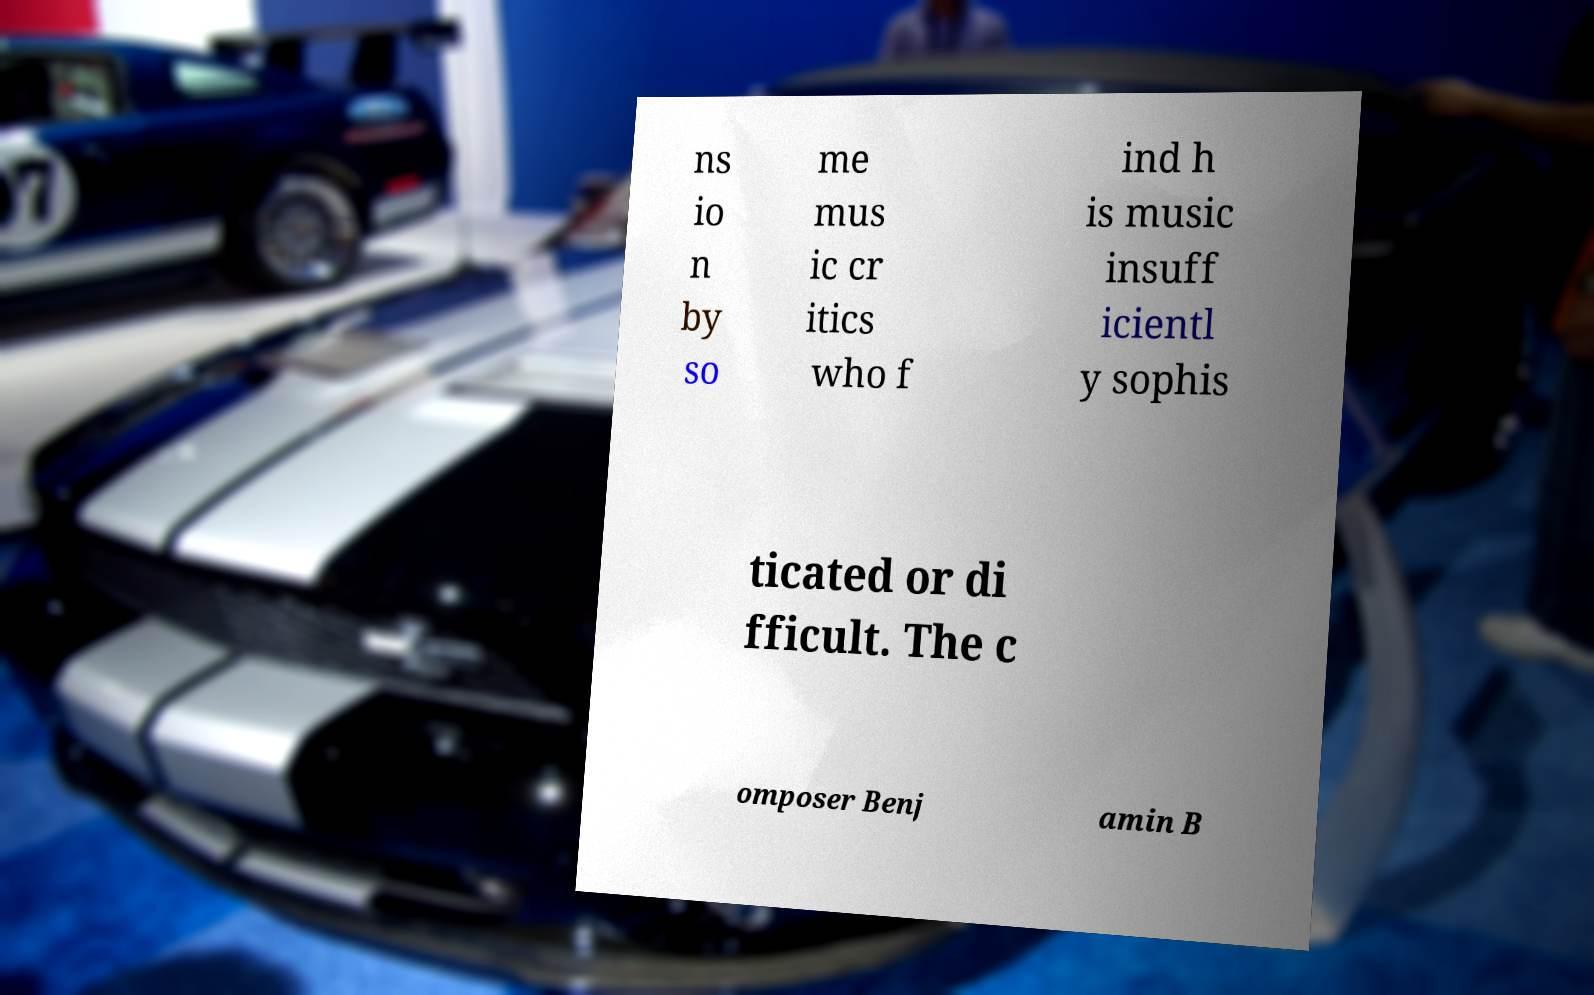Can you accurately transcribe the text from the provided image for me? ns io n by so me mus ic cr itics who f ind h is music insuff icientl y sophis ticated or di fficult. The c omposer Benj amin B 